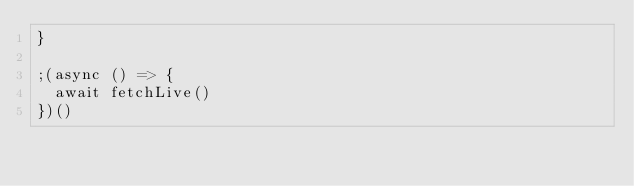Convert code to text. <code><loc_0><loc_0><loc_500><loc_500><_JavaScript_>}

;(async () => {
  await fetchLive()
})()
</code> 